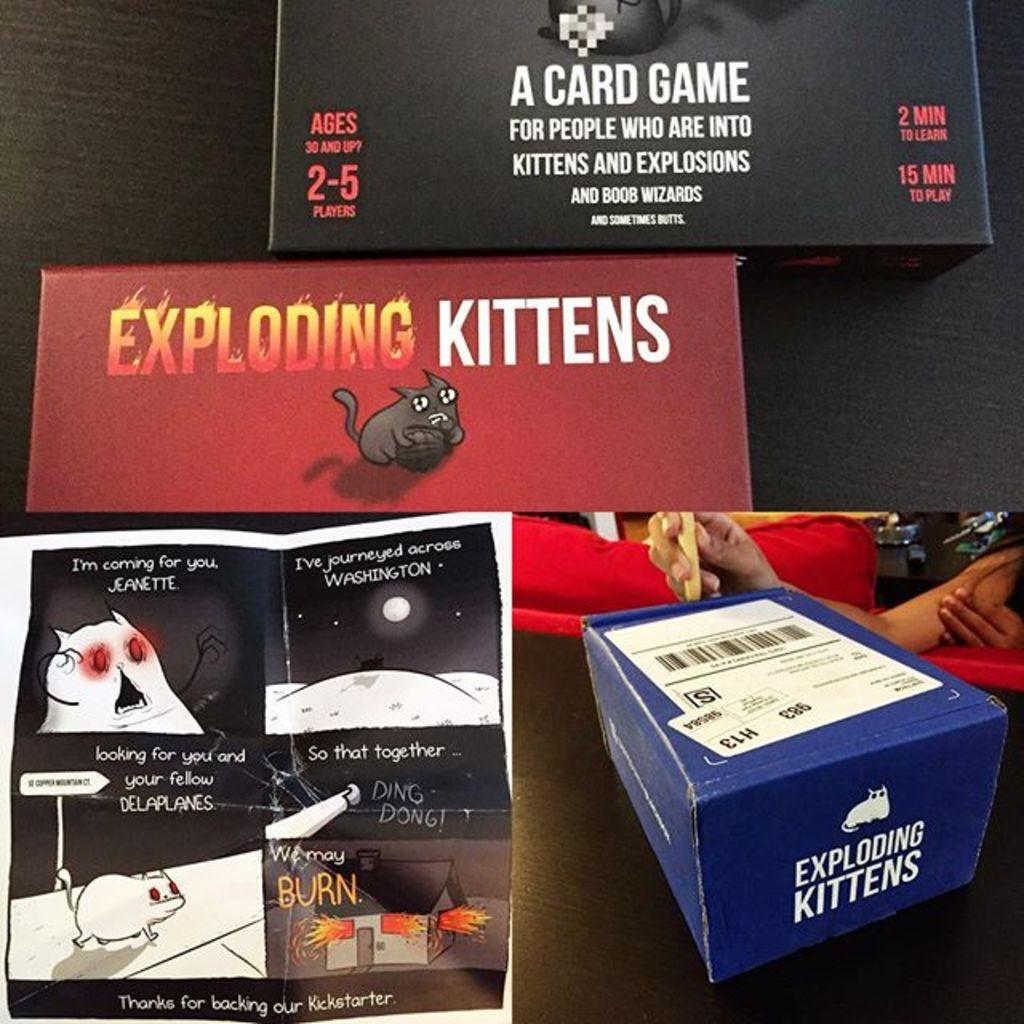<image>
Provide a brief description of the given image. Blue box that says Exploding Kittens next to a manual. 